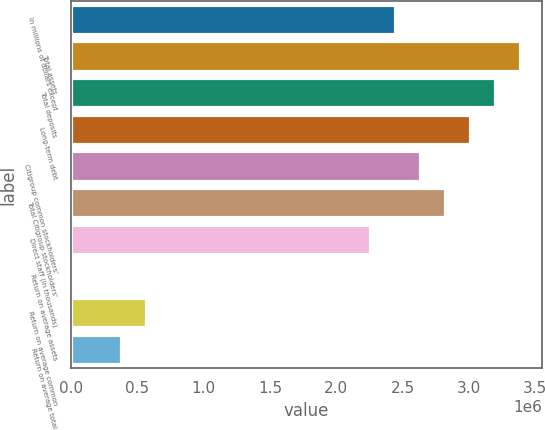Convert chart. <chart><loc_0><loc_0><loc_500><loc_500><bar_chart><fcel>In millions of dollars except<fcel>Total assets<fcel>Total deposits<fcel>Long-term debt<fcel>Citigroup common stockholders'<fcel>Total Citigroup stockholders'<fcel>Direct staff (in thousands)<fcel>Return on average assets<fcel>Return on average common<fcel>Return on average total<nl><fcel>2.44405e+06<fcel>3.38406e+06<fcel>3.19606e+06<fcel>3.00806e+06<fcel>2.63205e+06<fcel>2.82005e+06<fcel>2.25604e+06<fcel>0.73<fcel>564011<fcel>376008<nl></chart> 